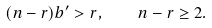<formula> <loc_0><loc_0><loc_500><loc_500>( n - r ) b ^ { \prime } > r , \quad n - r \geq 2 .</formula> 